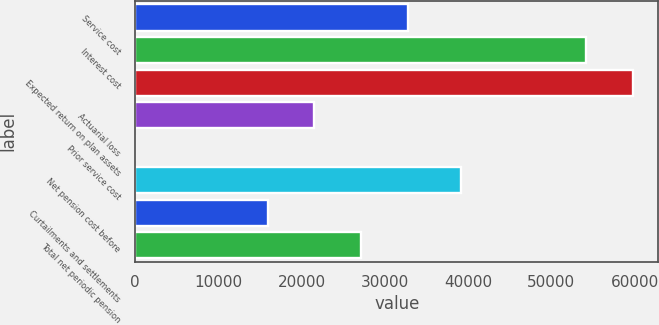<chart> <loc_0><loc_0><loc_500><loc_500><bar_chart><fcel>Service cost<fcel>Interest cost<fcel>Expected return on plan assets<fcel>Actuarial loss<fcel>Prior service cost<fcel>Net pension cost before<fcel>Curtailments and settlements<fcel>Total net periodic pension<nl><fcel>32803.8<fcel>54208<fcel>59844.6<fcel>21530.6<fcel>28<fcel>39153<fcel>15894<fcel>27167.2<nl></chart> 